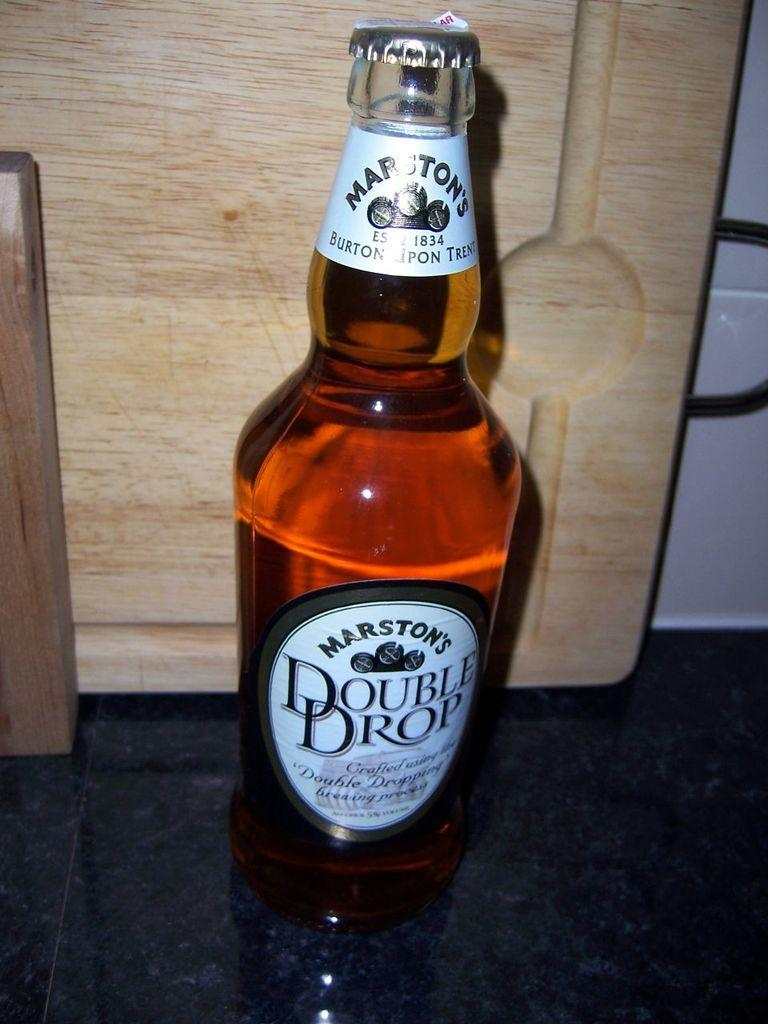<image>
Summarize the visual content of the image. a close up of Marston's double drop on a counter 